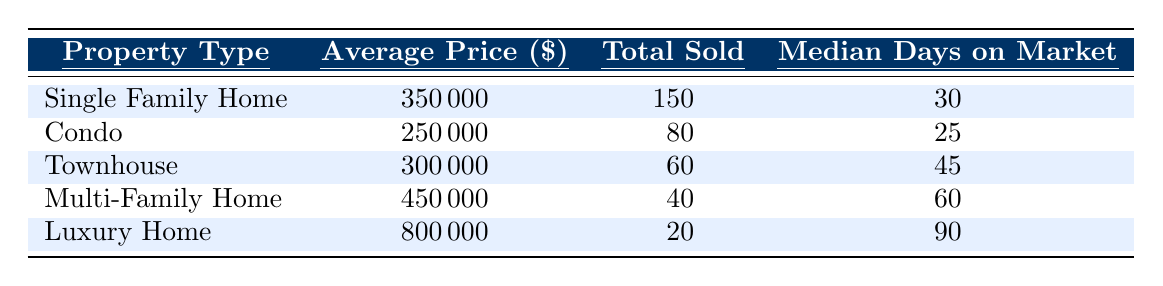What is the average price of a Single Family Home? The table shows that the average price for a Single Family Home is listed under the relevant column, which states $350,000.
Answer: 350000 How many Condo units were sold in the last quarter? The table indicates that a total of 80 Condo units were sold, as shown in the column for "Total Sold."
Answer: 80 What is the median days on market for Townhouses? Referring to the table, the median days on market for Townhouses is noted as 45 days.
Answer: 45 Which property type had the highest average price? The Luxury Home shows the highest average price of $800,000 compared to all other property types listed.
Answer: Luxury Home What is the total number of homes sold across all property types? To find this, I add the total number sold for each property type: 150 (Single Family) + 80 (Condo) + 60 (Townhouse) + 40 (Multi-Family) + 20 (Luxury) = 350.
Answer: 350 Did more Single Family Homes sell than Multi-Family Homes? The table shows that 150 Single Family Homes were sold, while only 40 Multi-Family Homes were sold. Hence, yes, more Single Family Homes sold.
Answer: Yes What is the difference in average price between Multi-Family Homes and Townhouses? The average price for Multi-Family Homes is $450,000 and for Townhouses, it is $300,000. The difference is calculated as $450,000 - $300,000 = $150,000.
Answer: 150000 Which property type sold the least number of units? The table indicates that the Multi-Family Home type had the lowest total sold at 40 units, lower than any other types listed.
Answer: Multi-Family Home How long, on average, do Luxury Homes stay on the market compared to Condos? The table shows Luxury Homes have a median of 90 days on market, while Condos have 25 days. The difference is 90 - 25 = 65 days longer for Luxury Homes.
Answer: 65 days What percentage of the total sales are Luxury Homes? First, calculate the total sales (350), then find the percentage of Luxury Homes sold (20 units): (20 / 350) * 100, which is about 5.71%.
Answer: 5.71% 